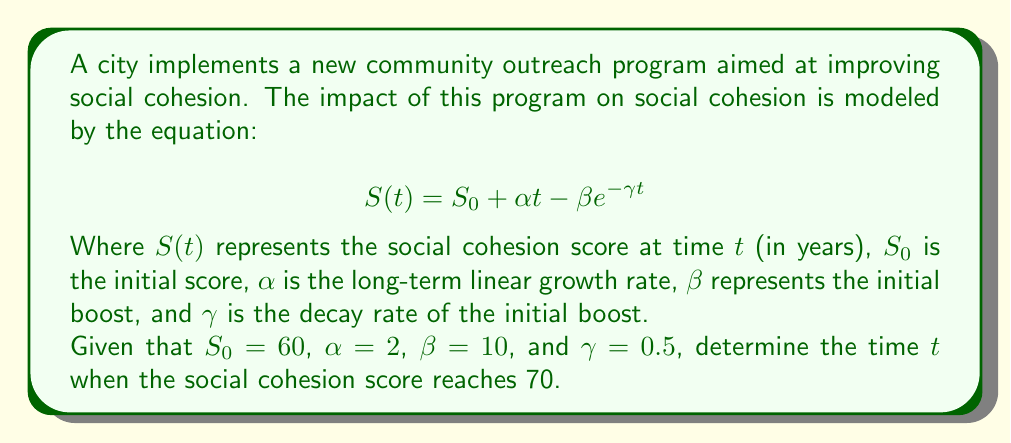Show me your answer to this math problem. To solve this inverse problem, we need to find $t$ when $S(t) = 70$. Let's approach this step-by-step:

1) We start with the equation:
   $$S(t) = S_0 + \alpha t - \beta e^{-\gamma t}$$

2) Substitute the known values:
   $$70 = 60 + 2t - 10e^{-0.5t}$$

3) Rearrange the equation:
   $$10 = 2t - 10e^{-0.5t}$$

4) Further simplify:
   $$5 = t - 5e^{-0.5t}$$

5) This equation cannot be solved algebraically. We need to use numerical methods, such as Newton's method or a graphical approach.

6) Using a numerical solver or graphing calculator, we can find that the solution is approximately:
   $$t \approx 3.86$$

7) We can verify this by plugging it back into the original equation:
   $$S(3.86) \approx 60 + 2(3.86) - 10e^{-0.5(3.86)} \approx 70$$

Therefore, the social cohesion score reaches 70 after approximately 3.86 years.
Answer: $t \approx 3.86$ years 